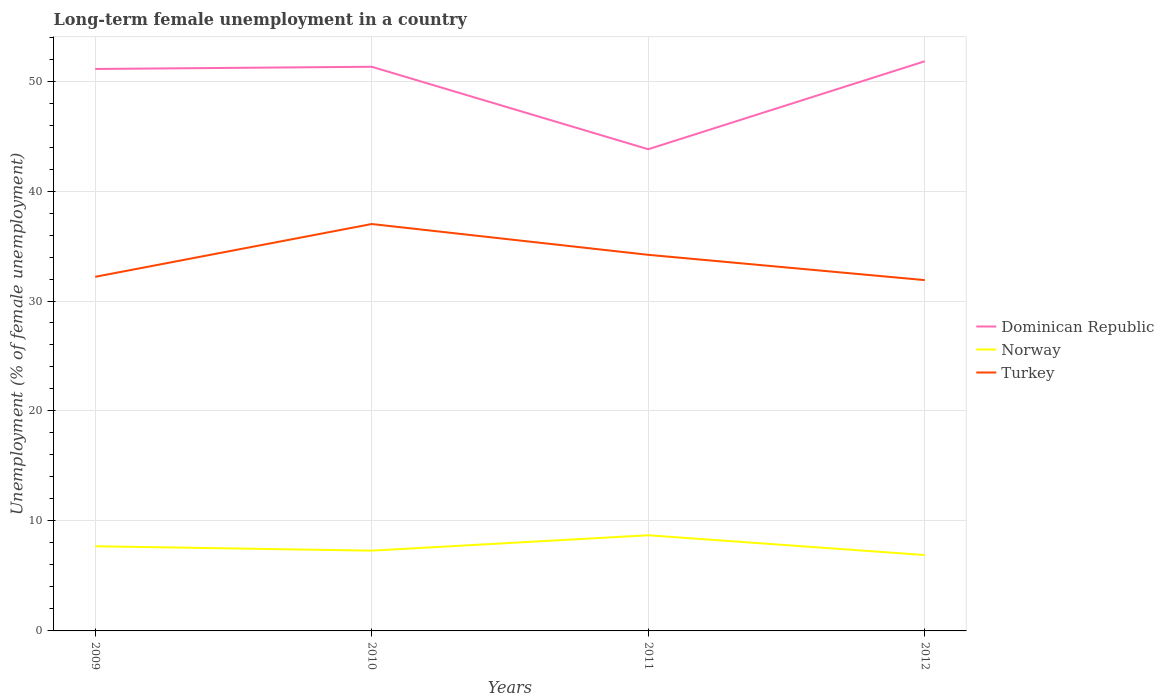How many different coloured lines are there?
Provide a succinct answer. 3. Is the number of lines equal to the number of legend labels?
Keep it short and to the point. Yes. Across all years, what is the maximum percentage of long-term unemployed female population in Norway?
Give a very brief answer. 6.9. What is the total percentage of long-term unemployed female population in Turkey in the graph?
Give a very brief answer. -4.8. What is the difference between the highest and the second highest percentage of long-term unemployed female population in Dominican Republic?
Ensure brevity in your answer.  8. What is the difference between the highest and the lowest percentage of long-term unemployed female population in Turkey?
Provide a succinct answer. 2. How many lines are there?
Make the answer very short. 3. Are the values on the major ticks of Y-axis written in scientific E-notation?
Make the answer very short. No. Does the graph contain any zero values?
Offer a very short reply. No. Does the graph contain grids?
Ensure brevity in your answer.  Yes. Where does the legend appear in the graph?
Make the answer very short. Center right. What is the title of the graph?
Your answer should be compact. Long-term female unemployment in a country. Does "Palau" appear as one of the legend labels in the graph?
Provide a succinct answer. No. What is the label or title of the Y-axis?
Your response must be concise. Unemployment (% of female unemployment). What is the Unemployment (% of female unemployment) of Dominican Republic in 2009?
Offer a terse response. 51.1. What is the Unemployment (% of female unemployment) in Norway in 2009?
Your answer should be very brief. 7.7. What is the Unemployment (% of female unemployment) in Turkey in 2009?
Provide a succinct answer. 32.2. What is the Unemployment (% of female unemployment) in Dominican Republic in 2010?
Keep it short and to the point. 51.3. What is the Unemployment (% of female unemployment) of Norway in 2010?
Ensure brevity in your answer.  7.3. What is the Unemployment (% of female unemployment) in Dominican Republic in 2011?
Offer a very short reply. 43.8. What is the Unemployment (% of female unemployment) in Norway in 2011?
Offer a very short reply. 8.7. What is the Unemployment (% of female unemployment) of Turkey in 2011?
Your answer should be compact. 34.2. What is the Unemployment (% of female unemployment) in Dominican Republic in 2012?
Offer a very short reply. 51.8. What is the Unemployment (% of female unemployment) of Norway in 2012?
Your answer should be compact. 6.9. What is the Unemployment (% of female unemployment) of Turkey in 2012?
Your response must be concise. 31.9. Across all years, what is the maximum Unemployment (% of female unemployment) in Dominican Republic?
Provide a succinct answer. 51.8. Across all years, what is the maximum Unemployment (% of female unemployment) of Norway?
Ensure brevity in your answer.  8.7. Across all years, what is the minimum Unemployment (% of female unemployment) in Dominican Republic?
Your answer should be very brief. 43.8. Across all years, what is the minimum Unemployment (% of female unemployment) of Norway?
Provide a short and direct response. 6.9. Across all years, what is the minimum Unemployment (% of female unemployment) in Turkey?
Your answer should be compact. 31.9. What is the total Unemployment (% of female unemployment) of Dominican Republic in the graph?
Offer a very short reply. 198. What is the total Unemployment (% of female unemployment) of Norway in the graph?
Your response must be concise. 30.6. What is the total Unemployment (% of female unemployment) in Turkey in the graph?
Offer a very short reply. 135.3. What is the difference between the Unemployment (% of female unemployment) in Dominican Republic in 2009 and that in 2011?
Offer a terse response. 7.3. What is the difference between the Unemployment (% of female unemployment) of Dominican Republic in 2009 and that in 2012?
Give a very brief answer. -0.7. What is the difference between the Unemployment (% of female unemployment) of Dominican Republic in 2010 and that in 2011?
Give a very brief answer. 7.5. What is the difference between the Unemployment (% of female unemployment) in Turkey in 2010 and that in 2011?
Keep it short and to the point. 2.8. What is the difference between the Unemployment (% of female unemployment) in Dominican Republic in 2010 and that in 2012?
Ensure brevity in your answer.  -0.5. What is the difference between the Unemployment (% of female unemployment) of Dominican Republic in 2011 and that in 2012?
Make the answer very short. -8. What is the difference between the Unemployment (% of female unemployment) in Norway in 2011 and that in 2012?
Give a very brief answer. 1.8. What is the difference between the Unemployment (% of female unemployment) in Dominican Republic in 2009 and the Unemployment (% of female unemployment) in Norway in 2010?
Give a very brief answer. 43.8. What is the difference between the Unemployment (% of female unemployment) in Dominican Republic in 2009 and the Unemployment (% of female unemployment) in Turkey in 2010?
Offer a terse response. 14.1. What is the difference between the Unemployment (% of female unemployment) of Norway in 2009 and the Unemployment (% of female unemployment) of Turkey in 2010?
Make the answer very short. -29.3. What is the difference between the Unemployment (% of female unemployment) of Dominican Republic in 2009 and the Unemployment (% of female unemployment) of Norway in 2011?
Provide a succinct answer. 42.4. What is the difference between the Unemployment (% of female unemployment) of Norway in 2009 and the Unemployment (% of female unemployment) of Turkey in 2011?
Ensure brevity in your answer.  -26.5. What is the difference between the Unemployment (% of female unemployment) in Dominican Republic in 2009 and the Unemployment (% of female unemployment) in Norway in 2012?
Your answer should be very brief. 44.2. What is the difference between the Unemployment (% of female unemployment) of Norway in 2009 and the Unemployment (% of female unemployment) of Turkey in 2012?
Provide a short and direct response. -24.2. What is the difference between the Unemployment (% of female unemployment) in Dominican Republic in 2010 and the Unemployment (% of female unemployment) in Norway in 2011?
Offer a very short reply. 42.6. What is the difference between the Unemployment (% of female unemployment) of Dominican Republic in 2010 and the Unemployment (% of female unemployment) of Turkey in 2011?
Provide a succinct answer. 17.1. What is the difference between the Unemployment (% of female unemployment) in Norway in 2010 and the Unemployment (% of female unemployment) in Turkey in 2011?
Offer a terse response. -26.9. What is the difference between the Unemployment (% of female unemployment) of Dominican Republic in 2010 and the Unemployment (% of female unemployment) of Norway in 2012?
Provide a succinct answer. 44.4. What is the difference between the Unemployment (% of female unemployment) in Dominican Republic in 2010 and the Unemployment (% of female unemployment) in Turkey in 2012?
Provide a succinct answer. 19.4. What is the difference between the Unemployment (% of female unemployment) in Norway in 2010 and the Unemployment (% of female unemployment) in Turkey in 2012?
Your response must be concise. -24.6. What is the difference between the Unemployment (% of female unemployment) in Dominican Republic in 2011 and the Unemployment (% of female unemployment) in Norway in 2012?
Your response must be concise. 36.9. What is the difference between the Unemployment (% of female unemployment) of Norway in 2011 and the Unemployment (% of female unemployment) of Turkey in 2012?
Your answer should be compact. -23.2. What is the average Unemployment (% of female unemployment) in Dominican Republic per year?
Your answer should be very brief. 49.5. What is the average Unemployment (% of female unemployment) of Norway per year?
Make the answer very short. 7.65. What is the average Unemployment (% of female unemployment) of Turkey per year?
Your answer should be very brief. 33.83. In the year 2009, what is the difference between the Unemployment (% of female unemployment) in Dominican Republic and Unemployment (% of female unemployment) in Norway?
Your answer should be very brief. 43.4. In the year 2009, what is the difference between the Unemployment (% of female unemployment) of Norway and Unemployment (% of female unemployment) of Turkey?
Keep it short and to the point. -24.5. In the year 2010, what is the difference between the Unemployment (% of female unemployment) in Dominican Republic and Unemployment (% of female unemployment) in Norway?
Make the answer very short. 44. In the year 2010, what is the difference between the Unemployment (% of female unemployment) in Norway and Unemployment (% of female unemployment) in Turkey?
Make the answer very short. -29.7. In the year 2011, what is the difference between the Unemployment (% of female unemployment) of Dominican Republic and Unemployment (% of female unemployment) of Norway?
Give a very brief answer. 35.1. In the year 2011, what is the difference between the Unemployment (% of female unemployment) in Dominican Republic and Unemployment (% of female unemployment) in Turkey?
Make the answer very short. 9.6. In the year 2011, what is the difference between the Unemployment (% of female unemployment) in Norway and Unemployment (% of female unemployment) in Turkey?
Keep it short and to the point. -25.5. In the year 2012, what is the difference between the Unemployment (% of female unemployment) in Dominican Republic and Unemployment (% of female unemployment) in Norway?
Make the answer very short. 44.9. In the year 2012, what is the difference between the Unemployment (% of female unemployment) in Norway and Unemployment (% of female unemployment) in Turkey?
Your response must be concise. -25. What is the ratio of the Unemployment (% of female unemployment) in Dominican Republic in 2009 to that in 2010?
Offer a terse response. 1. What is the ratio of the Unemployment (% of female unemployment) in Norway in 2009 to that in 2010?
Offer a terse response. 1.05. What is the ratio of the Unemployment (% of female unemployment) in Turkey in 2009 to that in 2010?
Your answer should be very brief. 0.87. What is the ratio of the Unemployment (% of female unemployment) in Dominican Republic in 2009 to that in 2011?
Provide a short and direct response. 1.17. What is the ratio of the Unemployment (% of female unemployment) in Norway in 2009 to that in 2011?
Offer a terse response. 0.89. What is the ratio of the Unemployment (% of female unemployment) of Turkey in 2009 to that in 2011?
Offer a terse response. 0.94. What is the ratio of the Unemployment (% of female unemployment) in Dominican Republic in 2009 to that in 2012?
Offer a very short reply. 0.99. What is the ratio of the Unemployment (% of female unemployment) in Norway in 2009 to that in 2012?
Ensure brevity in your answer.  1.12. What is the ratio of the Unemployment (% of female unemployment) of Turkey in 2009 to that in 2012?
Offer a very short reply. 1.01. What is the ratio of the Unemployment (% of female unemployment) in Dominican Republic in 2010 to that in 2011?
Your response must be concise. 1.17. What is the ratio of the Unemployment (% of female unemployment) of Norway in 2010 to that in 2011?
Give a very brief answer. 0.84. What is the ratio of the Unemployment (% of female unemployment) in Turkey in 2010 to that in 2011?
Make the answer very short. 1.08. What is the ratio of the Unemployment (% of female unemployment) in Dominican Republic in 2010 to that in 2012?
Your answer should be very brief. 0.99. What is the ratio of the Unemployment (% of female unemployment) of Norway in 2010 to that in 2012?
Your response must be concise. 1.06. What is the ratio of the Unemployment (% of female unemployment) in Turkey in 2010 to that in 2012?
Your response must be concise. 1.16. What is the ratio of the Unemployment (% of female unemployment) in Dominican Republic in 2011 to that in 2012?
Your response must be concise. 0.85. What is the ratio of the Unemployment (% of female unemployment) in Norway in 2011 to that in 2012?
Your answer should be compact. 1.26. What is the ratio of the Unemployment (% of female unemployment) in Turkey in 2011 to that in 2012?
Offer a terse response. 1.07. What is the difference between the highest and the second highest Unemployment (% of female unemployment) of Dominican Republic?
Give a very brief answer. 0.5. What is the difference between the highest and the second highest Unemployment (% of female unemployment) of Norway?
Keep it short and to the point. 1. What is the difference between the highest and the lowest Unemployment (% of female unemployment) of Turkey?
Your answer should be very brief. 5.1. 